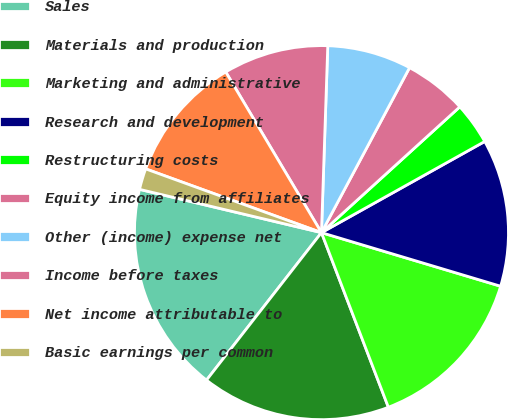Convert chart. <chart><loc_0><loc_0><loc_500><loc_500><pie_chart><fcel>Sales<fcel>Materials and production<fcel>Marketing and administrative<fcel>Research and development<fcel>Restructuring costs<fcel>Equity income from affiliates<fcel>Other (income) expense net<fcel>Income before taxes<fcel>Net income attributable to<fcel>Basic earnings per common<nl><fcel>18.18%<fcel>16.36%<fcel>14.55%<fcel>12.73%<fcel>3.64%<fcel>5.45%<fcel>7.27%<fcel>9.09%<fcel>10.91%<fcel>1.82%<nl></chart> 